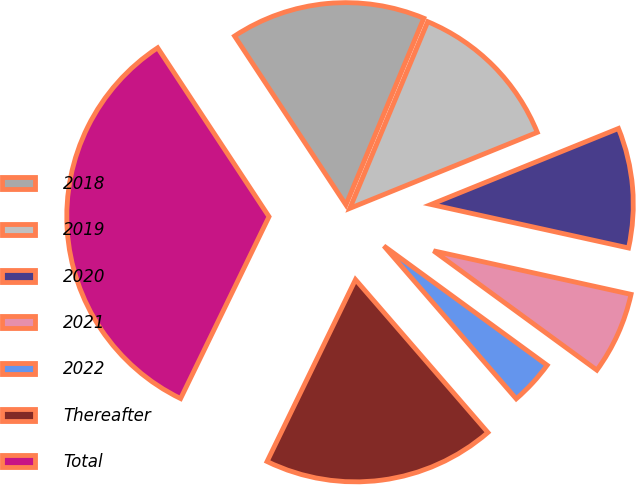<chart> <loc_0><loc_0><loc_500><loc_500><pie_chart><fcel>2018<fcel>2019<fcel>2020<fcel>2021<fcel>2022<fcel>Thereafter<fcel>Total<nl><fcel>15.57%<fcel>12.58%<fcel>9.58%<fcel>6.59%<fcel>3.6%<fcel>18.56%<fcel>33.52%<nl></chart> 